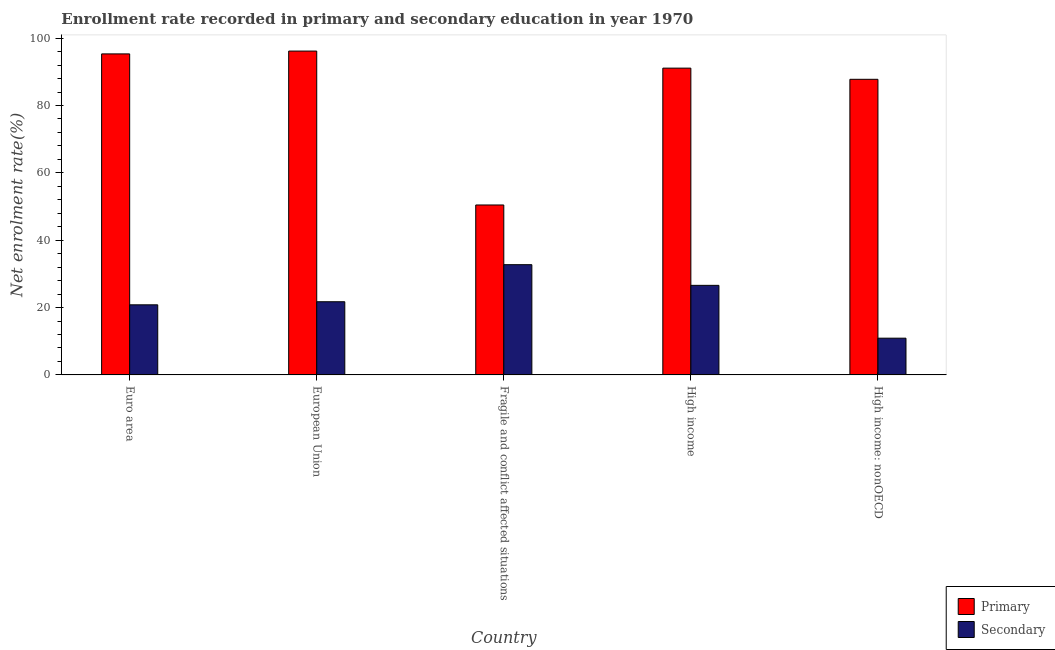Are the number of bars on each tick of the X-axis equal?
Provide a short and direct response. Yes. How many bars are there on the 1st tick from the right?
Your response must be concise. 2. What is the enrollment rate in primary education in High income: nonOECD?
Make the answer very short. 87.77. Across all countries, what is the maximum enrollment rate in secondary education?
Make the answer very short. 32.73. Across all countries, what is the minimum enrollment rate in secondary education?
Make the answer very short. 10.9. In which country was the enrollment rate in primary education minimum?
Offer a terse response. Fragile and conflict affected situations. What is the total enrollment rate in secondary education in the graph?
Offer a terse response. 112.76. What is the difference between the enrollment rate in primary education in Fragile and conflict affected situations and that in High income: nonOECD?
Keep it short and to the point. -37.32. What is the difference between the enrollment rate in secondary education in Euro area and the enrollment rate in primary education in European Union?
Ensure brevity in your answer.  -75.35. What is the average enrollment rate in secondary education per country?
Keep it short and to the point. 22.55. What is the difference between the enrollment rate in primary education and enrollment rate in secondary education in Fragile and conflict affected situations?
Your response must be concise. 17.73. What is the ratio of the enrollment rate in primary education in Fragile and conflict affected situations to that in High income?
Offer a very short reply. 0.55. Is the difference between the enrollment rate in primary education in Euro area and High income: nonOECD greater than the difference between the enrollment rate in secondary education in Euro area and High income: nonOECD?
Offer a very short reply. No. What is the difference between the highest and the second highest enrollment rate in primary education?
Provide a short and direct response. 0.84. What is the difference between the highest and the lowest enrollment rate in secondary education?
Provide a succinct answer. 21.83. In how many countries, is the enrollment rate in primary education greater than the average enrollment rate in primary education taken over all countries?
Your answer should be very brief. 4. Is the sum of the enrollment rate in secondary education in Euro area and Fragile and conflict affected situations greater than the maximum enrollment rate in primary education across all countries?
Offer a terse response. No. What does the 2nd bar from the left in European Union represents?
Provide a succinct answer. Secondary. What does the 2nd bar from the right in High income: nonOECD represents?
Provide a succinct answer. Primary. Are all the bars in the graph horizontal?
Your response must be concise. No. Are the values on the major ticks of Y-axis written in scientific E-notation?
Keep it short and to the point. No. Does the graph contain any zero values?
Ensure brevity in your answer.  No. Does the graph contain grids?
Offer a terse response. No. Where does the legend appear in the graph?
Offer a very short reply. Bottom right. How many legend labels are there?
Your answer should be very brief. 2. How are the legend labels stacked?
Your response must be concise. Vertical. What is the title of the graph?
Your response must be concise. Enrollment rate recorded in primary and secondary education in year 1970. Does "Mineral" appear as one of the legend labels in the graph?
Keep it short and to the point. No. What is the label or title of the Y-axis?
Provide a succinct answer. Net enrolment rate(%). What is the Net enrolment rate(%) of Primary in Euro area?
Offer a very short reply. 95.32. What is the Net enrolment rate(%) of Secondary in Euro area?
Ensure brevity in your answer.  20.81. What is the Net enrolment rate(%) in Primary in European Union?
Provide a succinct answer. 96.16. What is the Net enrolment rate(%) of Secondary in European Union?
Give a very brief answer. 21.73. What is the Net enrolment rate(%) in Primary in Fragile and conflict affected situations?
Offer a terse response. 50.46. What is the Net enrolment rate(%) in Secondary in Fragile and conflict affected situations?
Your answer should be very brief. 32.73. What is the Net enrolment rate(%) in Primary in High income?
Provide a succinct answer. 91.09. What is the Net enrolment rate(%) in Secondary in High income?
Make the answer very short. 26.59. What is the Net enrolment rate(%) in Primary in High income: nonOECD?
Your response must be concise. 87.77. What is the Net enrolment rate(%) of Secondary in High income: nonOECD?
Give a very brief answer. 10.9. Across all countries, what is the maximum Net enrolment rate(%) in Primary?
Keep it short and to the point. 96.16. Across all countries, what is the maximum Net enrolment rate(%) of Secondary?
Provide a short and direct response. 32.73. Across all countries, what is the minimum Net enrolment rate(%) of Primary?
Provide a succinct answer. 50.46. Across all countries, what is the minimum Net enrolment rate(%) in Secondary?
Your answer should be very brief. 10.9. What is the total Net enrolment rate(%) of Primary in the graph?
Provide a short and direct response. 420.8. What is the total Net enrolment rate(%) of Secondary in the graph?
Your answer should be compact. 112.76. What is the difference between the Net enrolment rate(%) in Primary in Euro area and that in European Union?
Give a very brief answer. -0.84. What is the difference between the Net enrolment rate(%) in Secondary in Euro area and that in European Union?
Offer a terse response. -0.92. What is the difference between the Net enrolment rate(%) in Primary in Euro area and that in Fragile and conflict affected situations?
Offer a terse response. 44.86. What is the difference between the Net enrolment rate(%) in Secondary in Euro area and that in Fragile and conflict affected situations?
Your answer should be compact. -11.92. What is the difference between the Net enrolment rate(%) of Primary in Euro area and that in High income?
Keep it short and to the point. 4.23. What is the difference between the Net enrolment rate(%) in Secondary in Euro area and that in High income?
Your response must be concise. -5.78. What is the difference between the Net enrolment rate(%) in Primary in Euro area and that in High income: nonOECD?
Give a very brief answer. 7.54. What is the difference between the Net enrolment rate(%) of Secondary in Euro area and that in High income: nonOECD?
Your response must be concise. 9.91. What is the difference between the Net enrolment rate(%) of Primary in European Union and that in Fragile and conflict affected situations?
Ensure brevity in your answer.  45.7. What is the difference between the Net enrolment rate(%) in Secondary in European Union and that in Fragile and conflict affected situations?
Keep it short and to the point. -11. What is the difference between the Net enrolment rate(%) of Primary in European Union and that in High income?
Provide a short and direct response. 5.07. What is the difference between the Net enrolment rate(%) of Secondary in European Union and that in High income?
Ensure brevity in your answer.  -4.86. What is the difference between the Net enrolment rate(%) in Primary in European Union and that in High income: nonOECD?
Give a very brief answer. 8.38. What is the difference between the Net enrolment rate(%) in Secondary in European Union and that in High income: nonOECD?
Your response must be concise. 10.82. What is the difference between the Net enrolment rate(%) in Primary in Fragile and conflict affected situations and that in High income?
Make the answer very short. -40.63. What is the difference between the Net enrolment rate(%) of Secondary in Fragile and conflict affected situations and that in High income?
Provide a short and direct response. 6.14. What is the difference between the Net enrolment rate(%) of Primary in Fragile and conflict affected situations and that in High income: nonOECD?
Your response must be concise. -37.32. What is the difference between the Net enrolment rate(%) of Secondary in Fragile and conflict affected situations and that in High income: nonOECD?
Offer a very short reply. 21.83. What is the difference between the Net enrolment rate(%) in Primary in High income and that in High income: nonOECD?
Your response must be concise. 3.32. What is the difference between the Net enrolment rate(%) of Secondary in High income and that in High income: nonOECD?
Give a very brief answer. 15.69. What is the difference between the Net enrolment rate(%) in Primary in Euro area and the Net enrolment rate(%) in Secondary in European Union?
Offer a terse response. 73.59. What is the difference between the Net enrolment rate(%) in Primary in Euro area and the Net enrolment rate(%) in Secondary in Fragile and conflict affected situations?
Offer a very short reply. 62.59. What is the difference between the Net enrolment rate(%) of Primary in Euro area and the Net enrolment rate(%) of Secondary in High income?
Provide a short and direct response. 68.73. What is the difference between the Net enrolment rate(%) of Primary in Euro area and the Net enrolment rate(%) of Secondary in High income: nonOECD?
Provide a succinct answer. 84.41. What is the difference between the Net enrolment rate(%) in Primary in European Union and the Net enrolment rate(%) in Secondary in Fragile and conflict affected situations?
Provide a short and direct response. 63.43. What is the difference between the Net enrolment rate(%) in Primary in European Union and the Net enrolment rate(%) in Secondary in High income?
Make the answer very short. 69.57. What is the difference between the Net enrolment rate(%) in Primary in European Union and the Net enrolment rate(%) in Secondary in High income: nonOECD?
Offer a very short reply. 85.25. What is the difference between the Net enrolment rate(%) in Primary in Fragile and conflict affected situations and the Net enrolment rate(%) in Secondary in High income?
Provide a short and direct response. 23.87. What is the difference between the Net enrolment rate(%) in Primary in Fragile and conflict affected situations and the Net enrolment rate(%) in Secondary in High income: nonOECD?
Give a very brief answer. 39.55. What is the difference between the Net enrolment rate(%) of Primary in High income and the Net enrolment rate(%) of Secondary in High income: nonOECD?
Your response must be concise. 80.19. What is the average Net enrolment rate(%) in Primary per country?
Keep it short and to the point. 84.16. What is the average Net enrolment rate(%) of Secondary per country?
Make the answer very short. 22.55. What is the difference between the Net enrolment rate(%) in Primary and Net enrolment rate(%) in Secondary in Euro area?
Provide a short and direct response. 74.51. What is the difference between the Net enrolment rate(%) in Primary and Net enrolment rate(%) in Secondary in European Union?
Ensure brevity in your answer.  74.43. What is the difference between the Net enrolment rate(%) of Primary and Net enrolment rate(%) of Secondary in Fragile and conflict affected situations?
Keep it short and to the point. 17.73. What is the difference between the Net enrolment rate(%) in Primary and Net enrolment rate(%) in Secondary in High income?
Your response must be concise. 64.5. What is the difference between the Net enrolment rate(%) in Primary and Net enrolment rate(%) in Secondary in High income: nonOECD?
Provide a succinct answer. 76.87. What is the ratio of the Net enrolment rate(%) of Primary in Euro area to that in European Union?
Give a very brief answer. 0.99. What is the ratio of the Net enrolment rate(%) in Secondary in Euro area to that in European Union?
Your answer should be very brief. 0.96. What is the ratio of the Net enrolment rate(%) in Primary in Euro area to that in Fragile and conflict affected situations?
Your response must be concise. 1.89. What is the ratio of the Net enrolment rate(%) of Secondary in Euro area to that in Fragile and conflict affected situations?
Give a very brief answer. 0.64. What is the ratio of the Net enrolment rate(%) of Primary in Euro area to that in High income?
Keep it short and to the point. 1.05. What is the ratio of the Net enrolment rate(%) of Secondary in Euro area to that in High income?
Provide a succinct answer. 0.78. What is the ratio of the Net enrolment rate(%) of Primary in Euro area to that in High income: nonOECD?
Offer a terse response. 1.09. What is the ratio of the Net enrolment rate(%) of Secondary in Euro area to that in High income: nonOECD?
Your answer should be compact. 1.91. What is the ratio of the Net enrolment rate(%) in Primary in European Union to that in Fragile and conflict affected situations?
Keep it short and to the point. 1.91. What is the ratio of the Net enrolment rate(%) in Secondary in European Union to that in Fragile and conflict affected situations?
Give a very brief answer. 0.66. What is the ratio of the Net enrolment rate(%) in Primary in European Union to that in High income?
Offer a very short reply. 1.06. What is the ratio of the Net enrolment rate(%) in Secondary in European Union to that in High income?
Give a very brief answer. 0.82. What is the ratio of the Net enrolment rate(%) of Primary in European Union to that in High income: nonOECD?
Give a very brief answer. 1.1. What is the ratio of the Net enrolment rate(%) in Secondary in European Union to that in High income: nonOECD?
Offer a very short reply. 1.99. What is the ratio of the Net enrolment rate(%) of Primary in Fragile and conflict affected situations to that in High income?
Give a very brief answer. 0.55. What is the ratio of the Net enrolment rate(%) in Secondary in Fragile and conflict affected situations to that in High income?
Offer a very short reply. 1.23. What is the ratio of the Net enrolment rate(%) of Primary in Fragile and conflict affected situations to that in High income: nonOECD?
Keep it short and to the point. 0.57. What is the ratio of the Net enrolment rate(%) of Secondary in Fragile and conflict affected situations to that in High income: nonOECD?
Offer a very short reply. 3. What is the ratio of the Net enrolment rate(%) in Primary in High income to that in High income: nonOECD?
Your answer should be compact. 1.04. What is the ratio of the Net enrolment rate(%) of Secondary in High income to that in High income: nonOECD?
Ensure brevity in your answer.  2.44. What is the difference between the highest and the second highest Net enrolment rate(%) of Primary?
Provide a succinct answer. 0.84. What is the difference between the highest and the second highest Net enrolment rate(%) in Secondary?
Keep it short and to the point. 6.14. What is the difference between the highest and the lowest Net enrolment rate(%) in Primary?
Provide a succinct answer. 45.7. What is the difference between the highest and the lowest Net enrolment rate(%) in Secondary?
Ensure brevity in your answer.  21.83. 